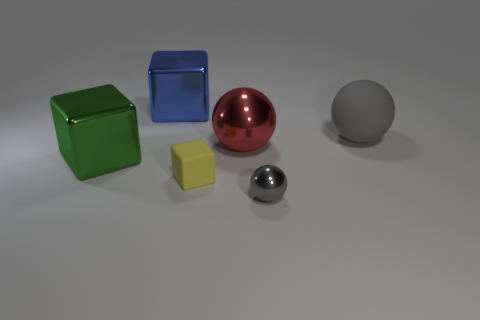Add 1 large metallic balls. How many objects exist? 7 Add 1 large green blocks. How many large green blocks exist? 2 Subtract 0 purple cylinders. How many objects are left? 6 Subtract all red things. Subtract all tiny blue objects. How many objects are left? 5 Add 1 large gray objects. How many large gray objects are left? 2 